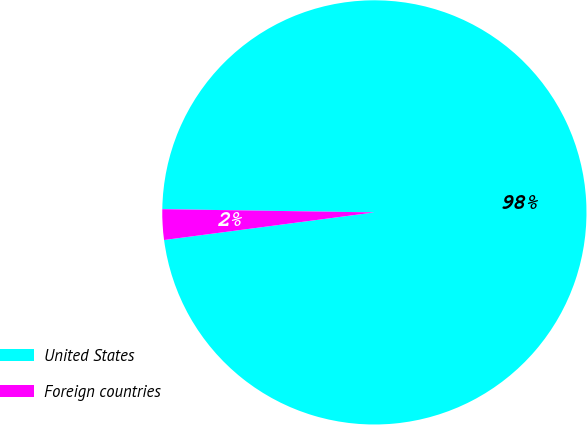<chart> <loc_0><loc_0><loc_500><loc_500><pie_chart><fcel>United States<fcel>Foreign countries<nl><fcel>97.68%<fcel>2.32%<nl></chart> 